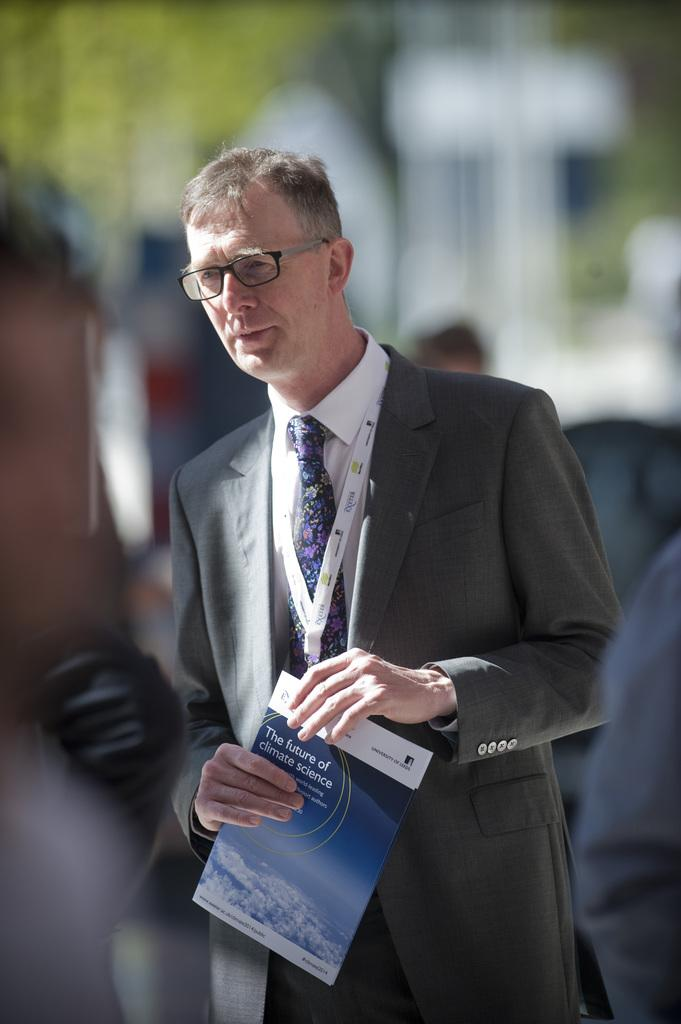What is the person in the image holding? The person is holding a book in the image. Are there any other people visible in the image? Yes, there are other people behind the person holding the book. Can you describe the background of the image? The background of the image is blurred. What type of toys can be seen in the image? There are no toys present in the image. What time of day is it in the image? The time of day cannot be determined from the image. 